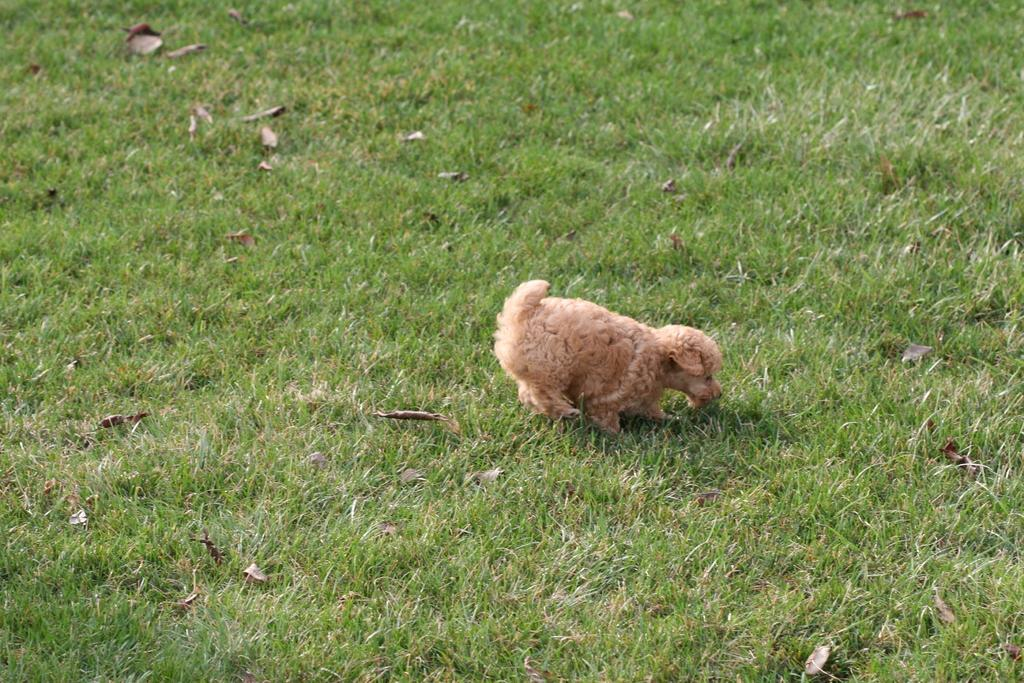What animal is present in the image? There is a dog in the image. Where is the dog located? The dog is on a grass field. What type of butter can be seen melting on the church in the image? There is no butter or church present in the image; it features a dog on a grass field. 